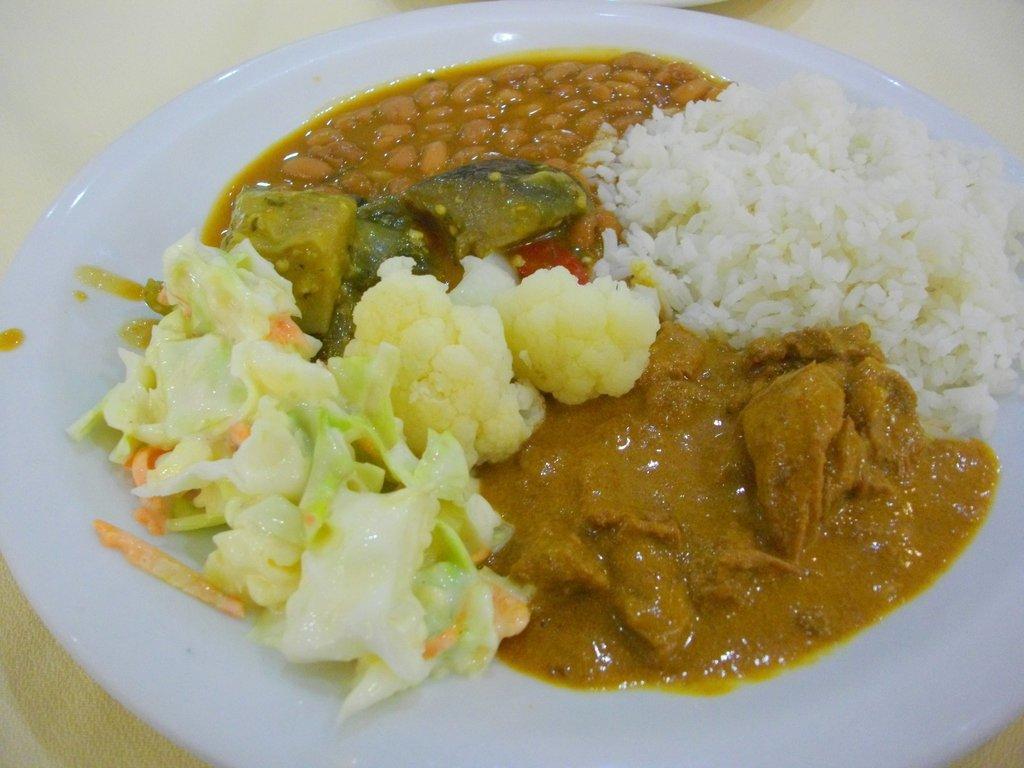Could you give a brief overview of what you see in this image? In this picture we can see a plate, on this plate we can see food items and this plate is placed on a platform. 